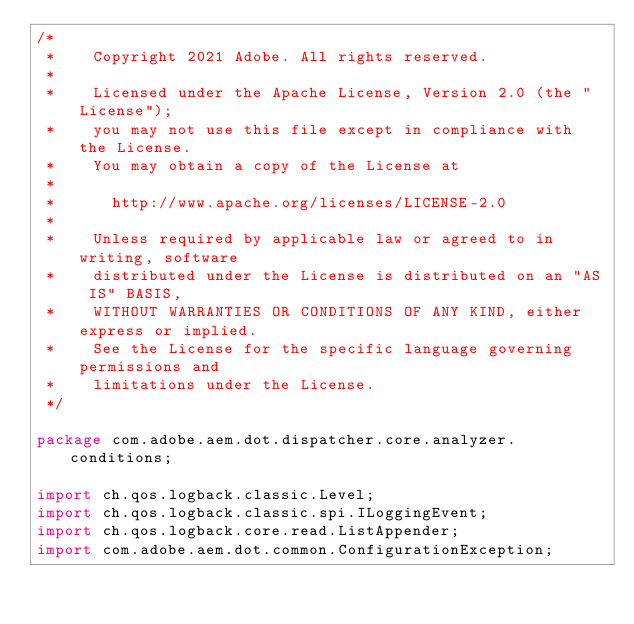<code> <loc_0><loc_0><loc_500><loc_500><_Java_>/*
 *    Copyright 2021 Adobe. All rights reserved.
 *
 *    Licensed under the Apache License, Version 2.0 (the "License");
 *    you may not use this file except in compliance with the License.
 *    You may obtain a copy of the License at
 *
 *      http://www.apache.org/licenses/LICENSE-2.0
 *
 *    Unless required by applicable law or agreed to in writing, software
 *    distributed under the License is distributed on an "AS IS" BASIS,
 *    WITHOUT WARRANTIES OR CONDITIONS OF ANY KIND, either express or implied.
 *    See the License for the specific language governing permissions and
 *    limitations under the License.
 */

package com.adobe.aem.dot.dispatcher.core.analyzer.conditions;

import ch.qos.logback.classic.Level;
import ch.qos.logback.classic.spi.ILoggingEvent;
import ch.qos.logback.core.read.ListAppender;
import com.adobe.aem.dot.common.ConfigurationException;</code> 